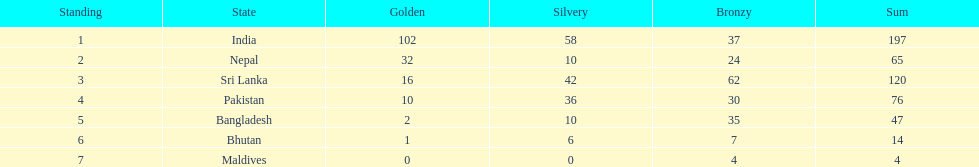How many gold medals did india win? 102. 